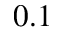<formula> <loc_0><loc_0><loc_500><loc_500>0 . 1</formula> 